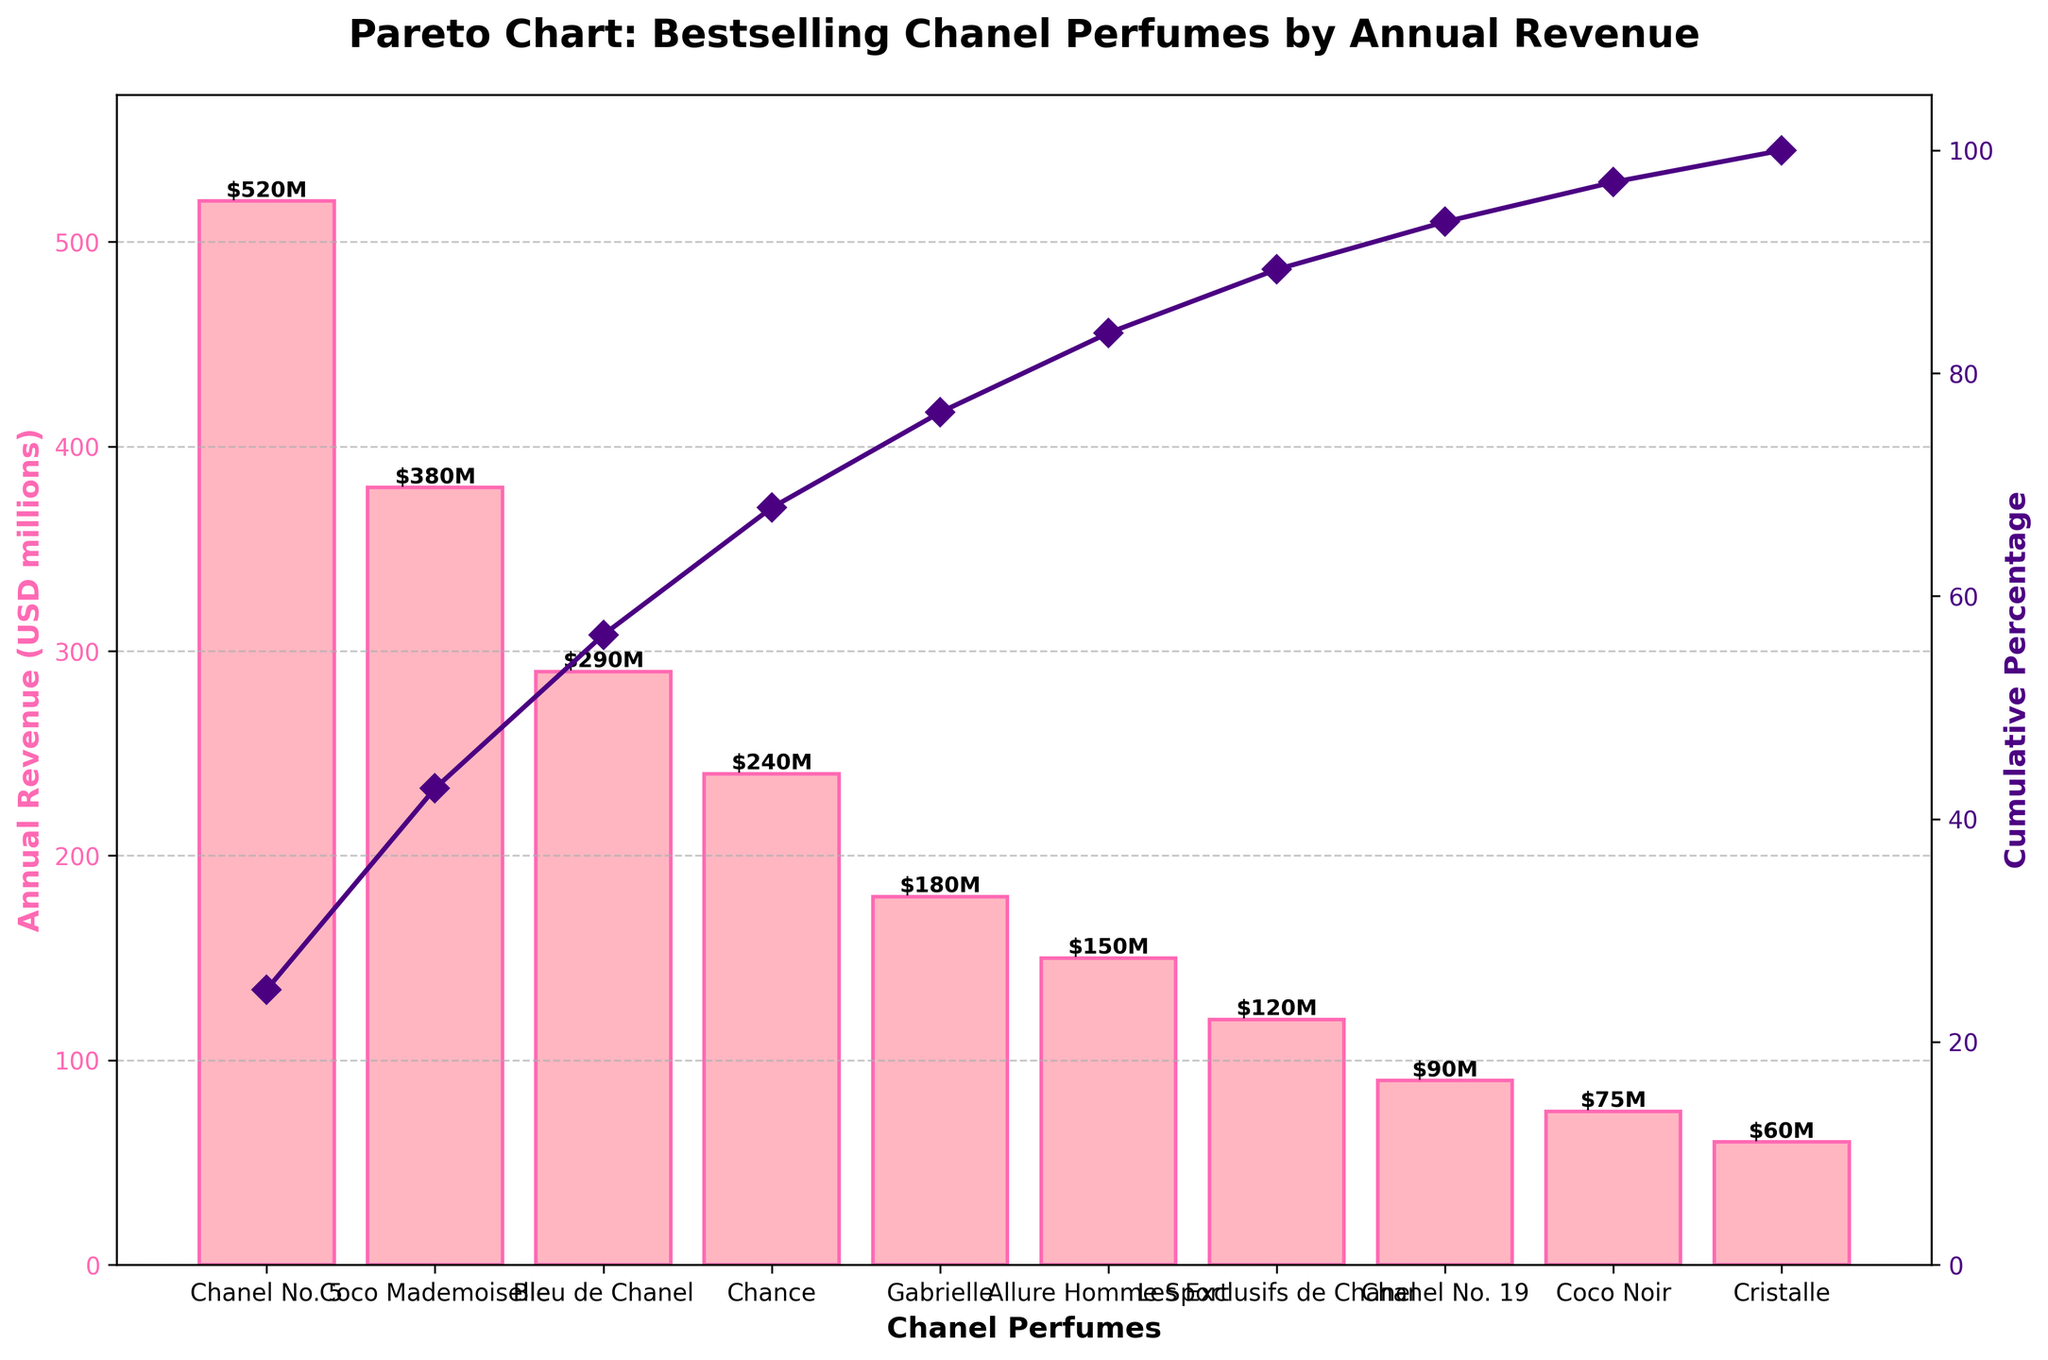what's the title of the chart? The title is typically found at the top of the chart, providing a brief description of what the chart represents. Here, it states the chart is about "Bestselling Chanel Perfumes by Annual Revenue".
Answer: Pareto Chart: Bestselling Chanel Perfumes by Annual Revenue which Chanel perfume has the highest annual revenue? To find this, look for the tallest bar on the chart. The tallest bar represents the perfume with the highest annual revenue.
Answer: Chanel No. 5 what percentage of total annual revenue does Coco Mademoiselle contribute? First, locate the bar for Coco Mademoiselle, then identify the cumulative percentage line corresponding to that bar's top.
Answer: About 48% what are the annual revenues of Bleu de Chanel and Chance combined? Identify and add the heights (in USD millions) of the bars for Bleu de Chanel and Chance: $290M and $240M respectively.
Answer: $530 million which product is just above Coco Noir in terms of annual revenue? Find the bar for Coco Noir and look for the next higher bar immediately to the left.
Answer: Chanel No. 19 how many products contribute to the first 80% of the revenue? Follow the cumulative percentage line up to 80% and count the number of bars from the left until 80% is reached.
Answer: Four products is Allure Homme Sport's annual revenue more than a third of Chanel No. 5's annual revenue? Compare 1/3 of Chanel No. 5's revenue ($520M / 3 ≈ $173.33M) to Allure Homme Sport's revenue ($150M).
Answer: No which product has a lower annual revenue: Gabrielle or Les Exclusifs de Chanel? Compare the heights of the bars for Gabrielle and Les Exclusifs de Chanel.
Answer: Les Exclusifs de Chanel what is the cumulative percentage after the fifth product? Count five bars from the left and follow the cumulative percentage line at the top of the fifth bar.
Answer: About 81% how much is the difference in annual revenue between Chanel No. 19 and Coco Noir? Subtract Coco Noir's revenue by Chanel No. 19's revenue ($90M - $75M).
Answer: $15 million 